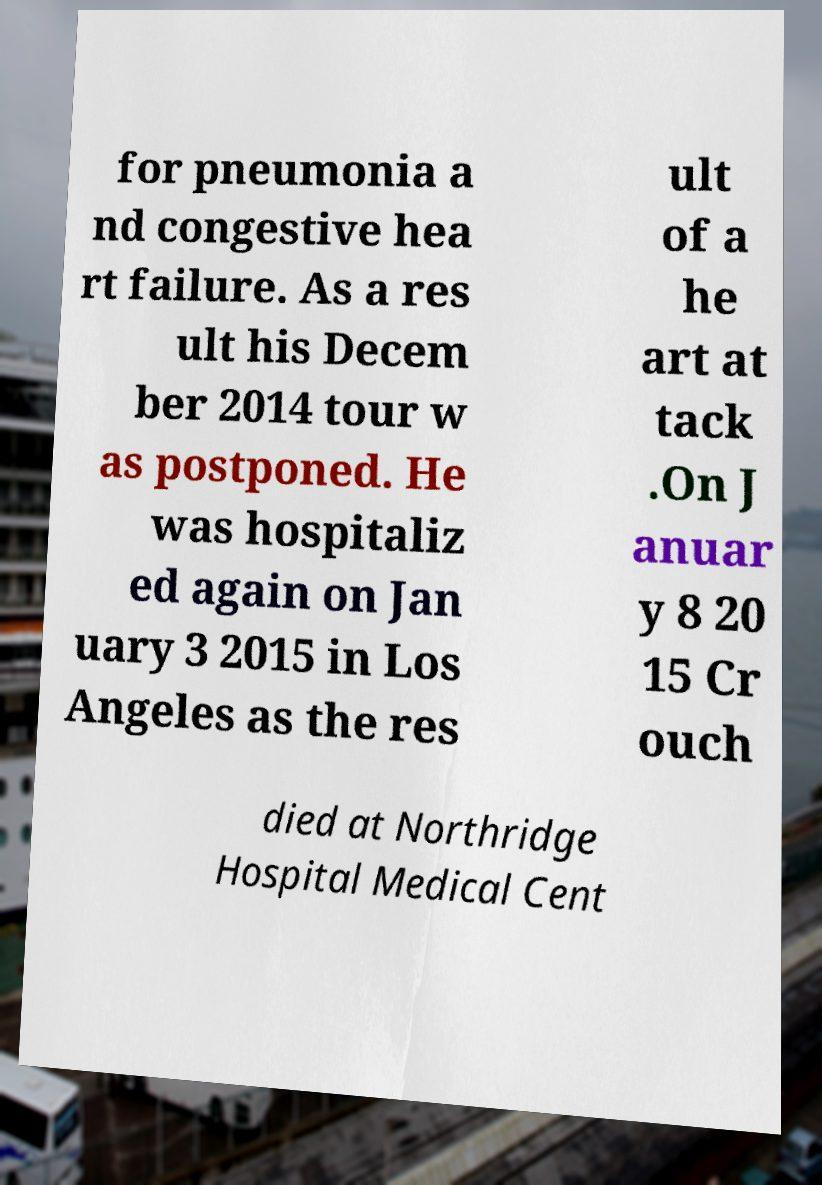Could you extract and type out the text from this image? for pneumonia a nd congestive hea rt failure. As a res ult his Decem ber 2014 tour w as postponed. He was hospitaliz ed again on Jan uary 3 2015 in Los Angeles as the res ult of a he art at tack .On J anuar y 8 20 15 Cr ouch died at Northridge Hospital Medical Cent 